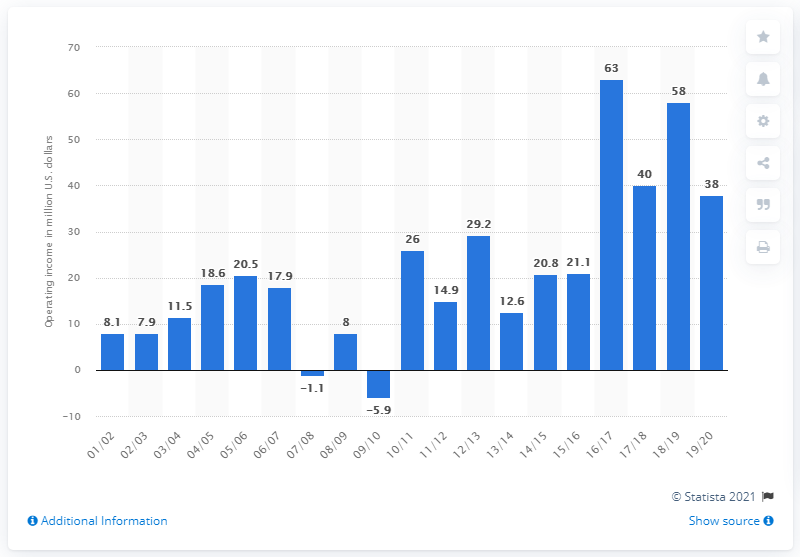List a handful of essential elements in this visual. The operating income of the Miami Heat in the 2019/20 season was 38. 